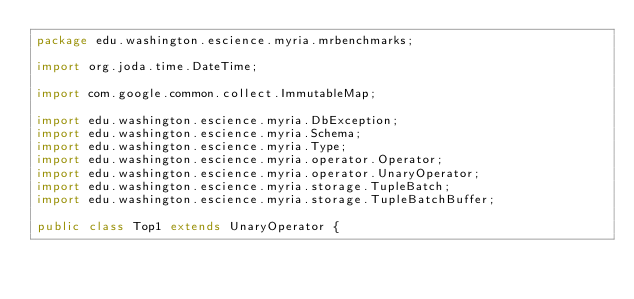Convert code to text. <code><loc_0><loc_0><loc_500><loc_500><_Java_>package edu.washington.escience.myria.mrbenchmarks;

import org.joda.time.DateTime;

import com.google.common.collect.ImmutableMap;

import edu.washington.escience.myria.DbException;
import edu.washington.escience.myria.Schema;
import edu.washington.escience.myria.Type;
import edu.washington.escience.myria.operator.Operator;
import edu.washington.escience.myria.operator.UnaryOperator;
import edu.washington.escience.myria.storage.TupleBatch;
import edu.washington.escience.myria.storage.TupleBatchBuffer;

public class Top1 extends UnaryOperator {
</code> 